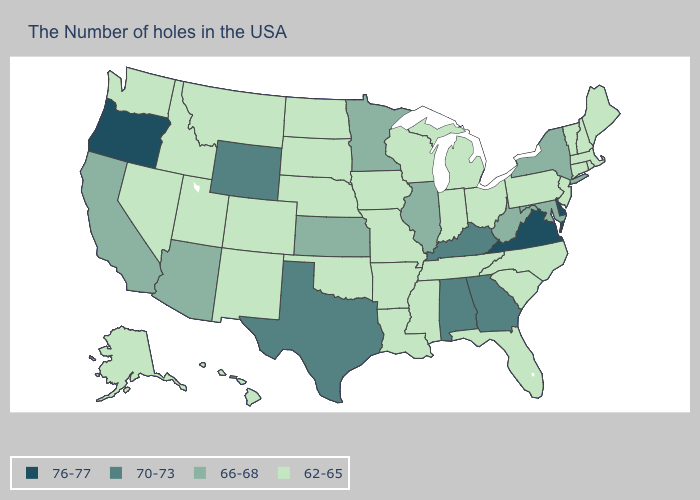Which states have the lowest value in the South?
Write a very short answer. North Carolina, South Carolina, Florida, Tennessee, Mississippi, Louisiana, Arkansas, Oklahoma. Name the states that have a value in the range 62-65?
Be succinct. Maine, Massachusetts, Rhode Island, New Hampshire, Vermont, Connecticut, New Jersey, Pennsylvania, North Carolina, South Carolina, Ohio, Florida, Michigan, Indiana, Tennessee, Wisconsin, Mississippi, Louisiana, Missouri, Arkansas, Iowa, Nebraska, Oklahoma, South Dakota, North Dakota, Colorado, New Mexico, Utah, Montana, Idaho, Nevada, Washington, Alaska, Hawaii. Is the legend a continuous bar?
Quick response, please. No. Which states have the lowest value in the USA?
Quick response, please. Maine, Massachusetts, Rhode Island, New Hampshire, Vermont, Connecticut, New Jersey, Pennsylvania, North Carolina, South Carolina, Ohio, Florida, Michigan, Indiana, Tennessee, Wisconsin, Mississippi, Louisiana, Missouri, Arkansas, Iowa, Nebraska, Oklahoma, South Dakota, North Dakota, Colorado, New Mexico, Utah, Montana, Idaho, Nevada, Washington, Alaska, Hawaii. Is the legend a continuous bar?
Concise answer only. No. What is the lowest value in the USA?
Keep it brief. 62-65. What is the value of Pennsylvania?
Be succinct. 62-65. Name the states that have a value in the range 70-73?
Keep it brief. Georgia, Kentucky, Alabama, Texas, Wyoming. Name the states that have a value in the range 76-77?
Give a very brief answer. Delaware, Virginia, Oregon. Name the states that have a value in the range 62-65?
Be succinct. Maine, Massachusetts, Rhode Island, New Hampshire, Vermont, Connecticut, New Jersey, Pennsylvania, North Carolina, South Carolina, Ohio, Florida, Michigan, Indiana, Tennessee, Wisconsin, Mississippi, Louisiana, Missouri, Arkansas, Iowa, Nebraska, Oklahoma, South Dakota, North Dakota, Colorado, New Mexico, Utah, Montana, Idaho, Nevada, Washington, Alaska, Hawaii. Which states have the highest value in the USA?
Quick response, please. Delaware, Virginia, Oregon. What is the value of Missouri?
Write a very short answer. 62-65. What is the lowest value in the West?
Answer briefly. 62-65. What is the value of Washington?
Quick response, please. 62-65. Among the states that border Delaware , which have the lowest value?
Keep it brief. New Jersey, Pennsylvania. 